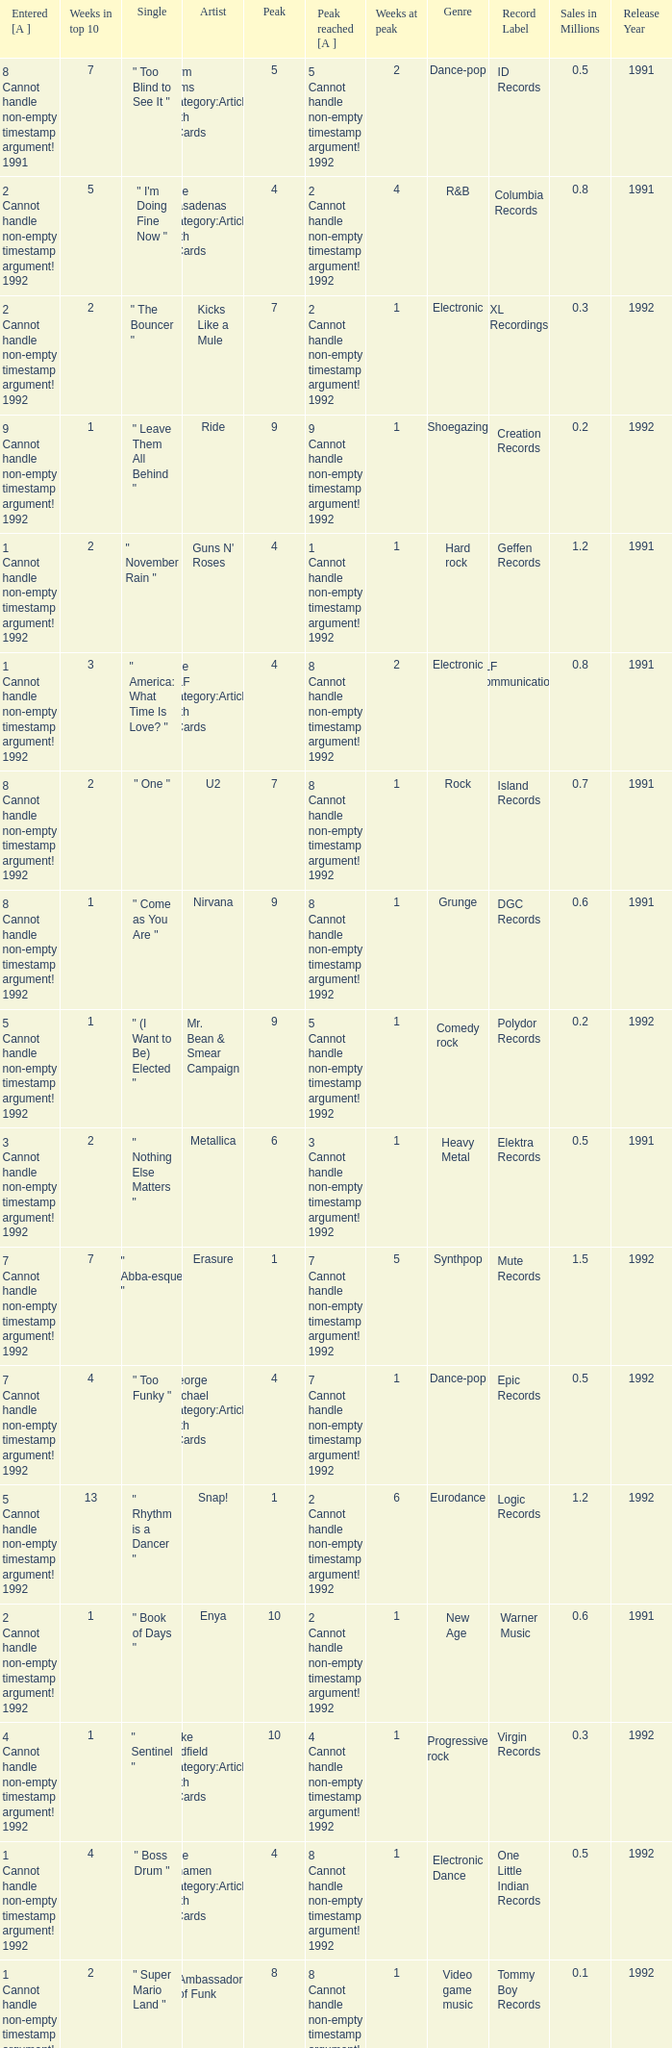If the peak is 9, how many weeks was it in the top 10? 1.0. 